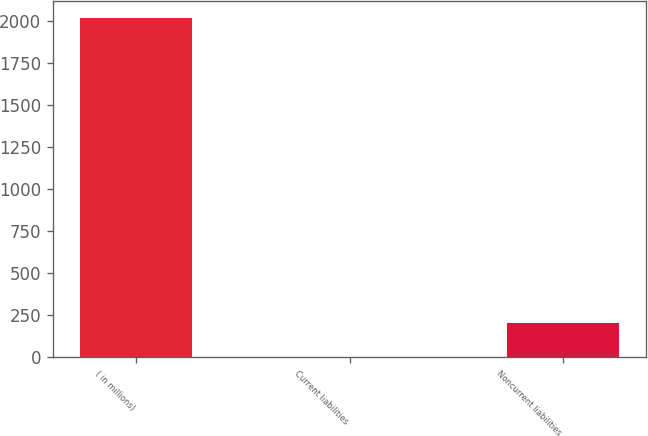<chart> <loc_0><loc_0><loc_500><loc_500><bar_chart><fcel>( in millions)<fcel>Current liabilities<fcel>Noncurrent liabilities<nl><fcel>2016<fcel>0.7<fcel>202.23<nl></chart> 